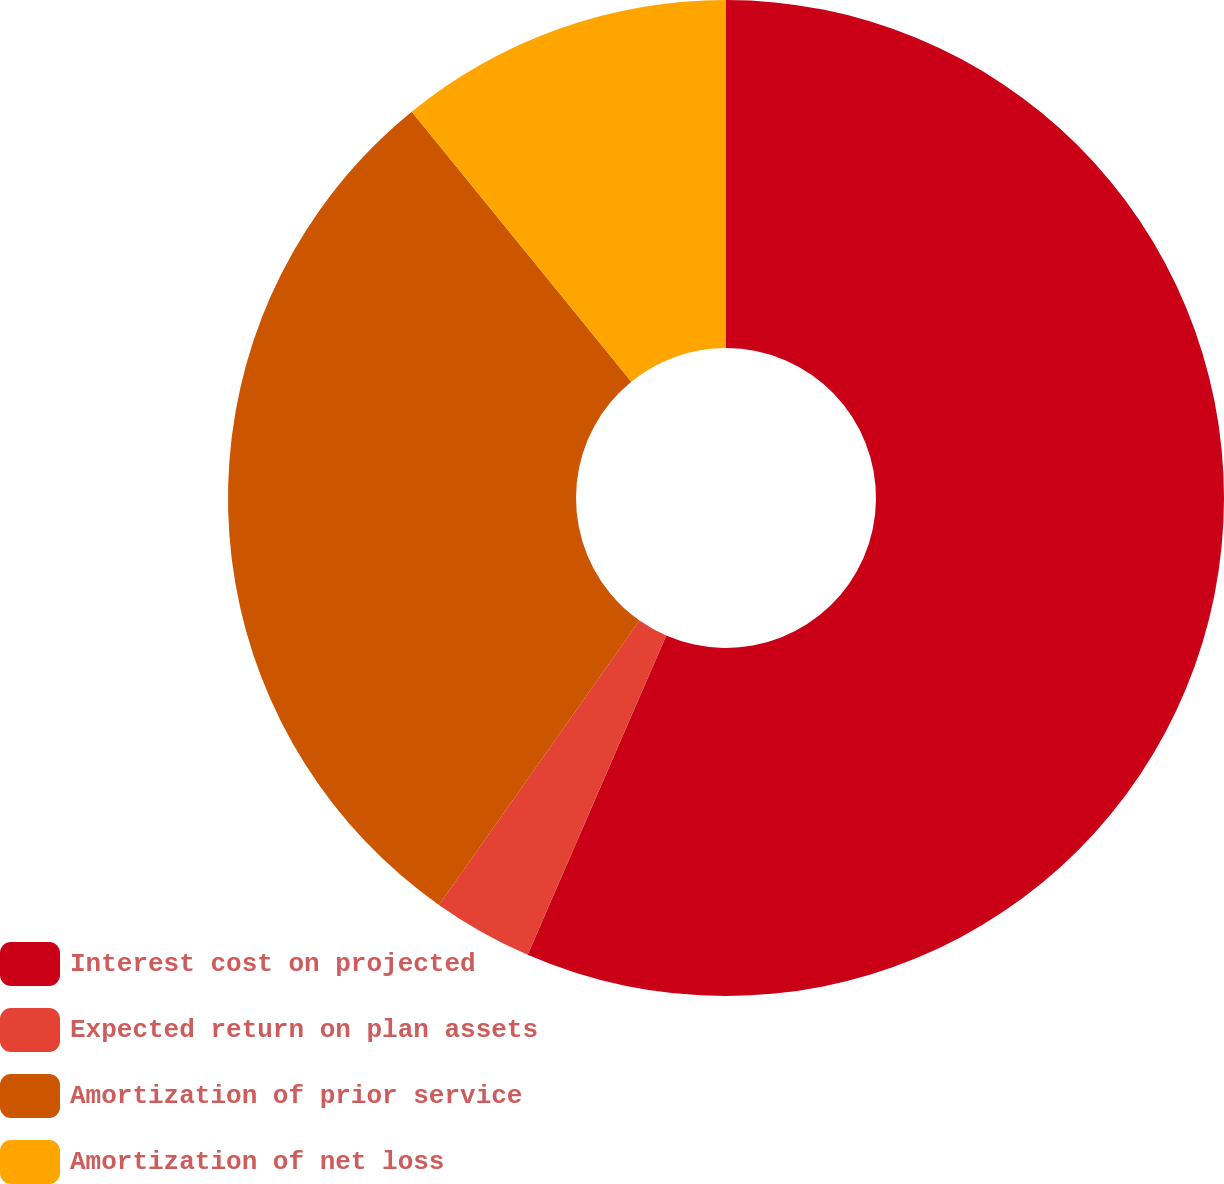Convert chart. <chart><loc_0><loc_0><loc_500><loc_500><pie_chart><fcel>Interest cost on projected<fcel>Expected return on plan assets<fcel>Amortization of prior service<fcel>Amortization of net loss<nl><fcel>56.52%<fcel>3.26%<fcel>29.35%<fcel>10.87%<nl></chart> 